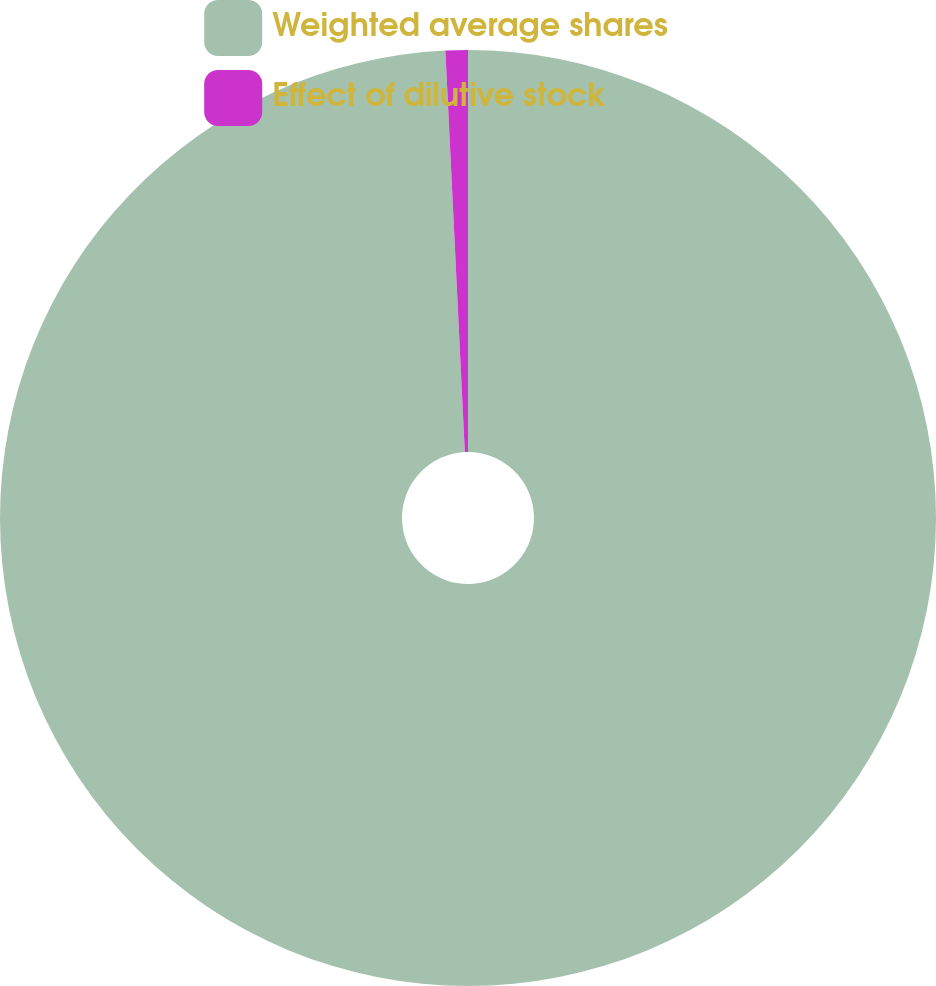<chart> <loc_0><loc_0><loc_500><loc_500><pie_chart><fcel>Weighted average shares<fcel>Effect of dilutive stock<nl><fcel>99.23%<fcel>0.77%<nl></chart> 